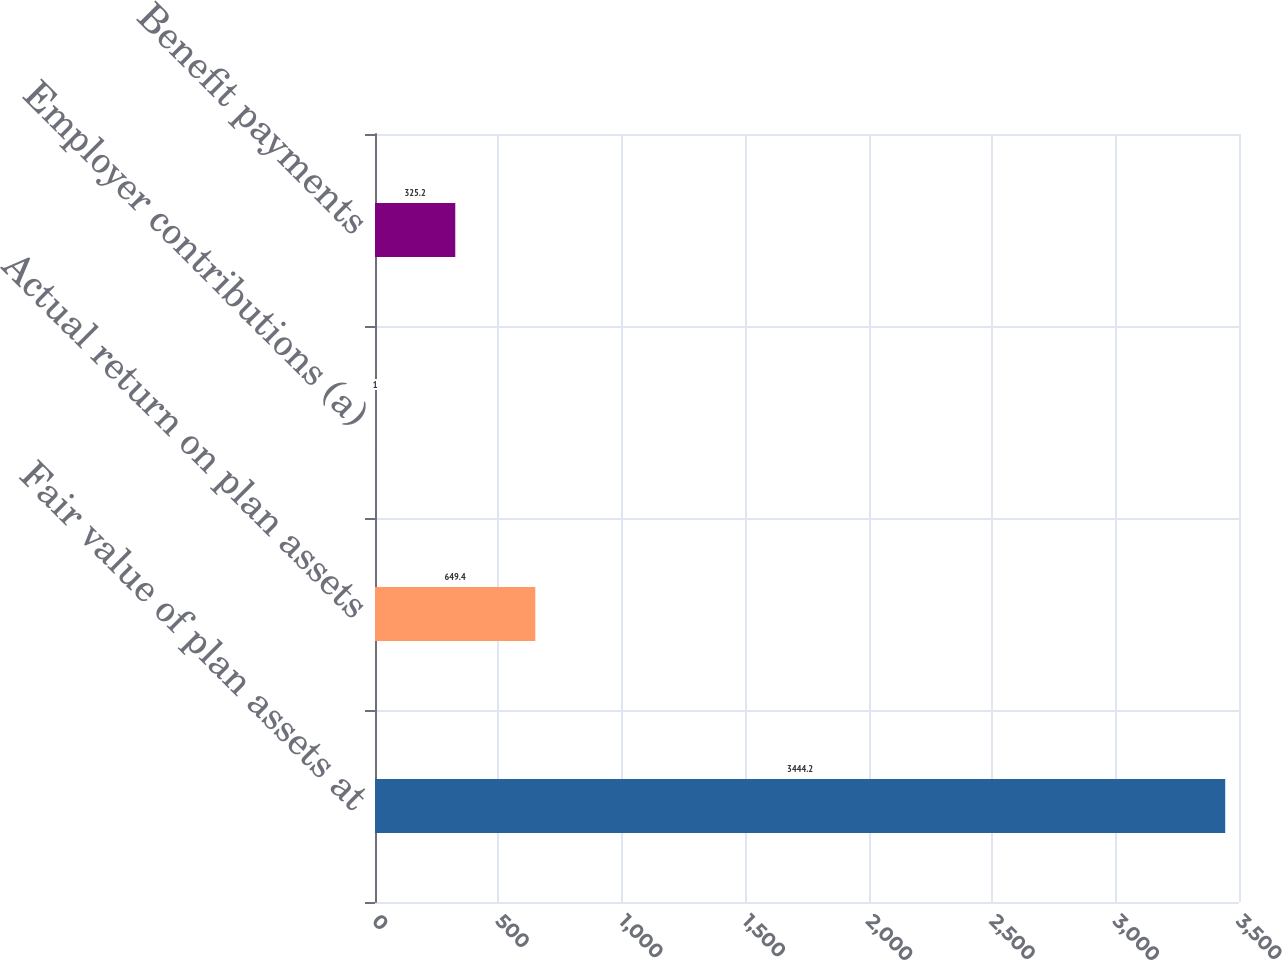Convert chart. <chart><loc_0><loc_0><loc_500><loc_500><bar_chart><fcel>Fair value of plan assets at<fcel>Actual return on plan assets<fcel>Employer contributions (a)<fcel>Benefit payments<nl><fcel>3444.2<fcel>649.4<fcel>1<fcel>325.2<nl></chart> 